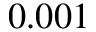<formula> <loc_0><loc_0><loc_500><loc_500>0 . 0 0 1</formula> 